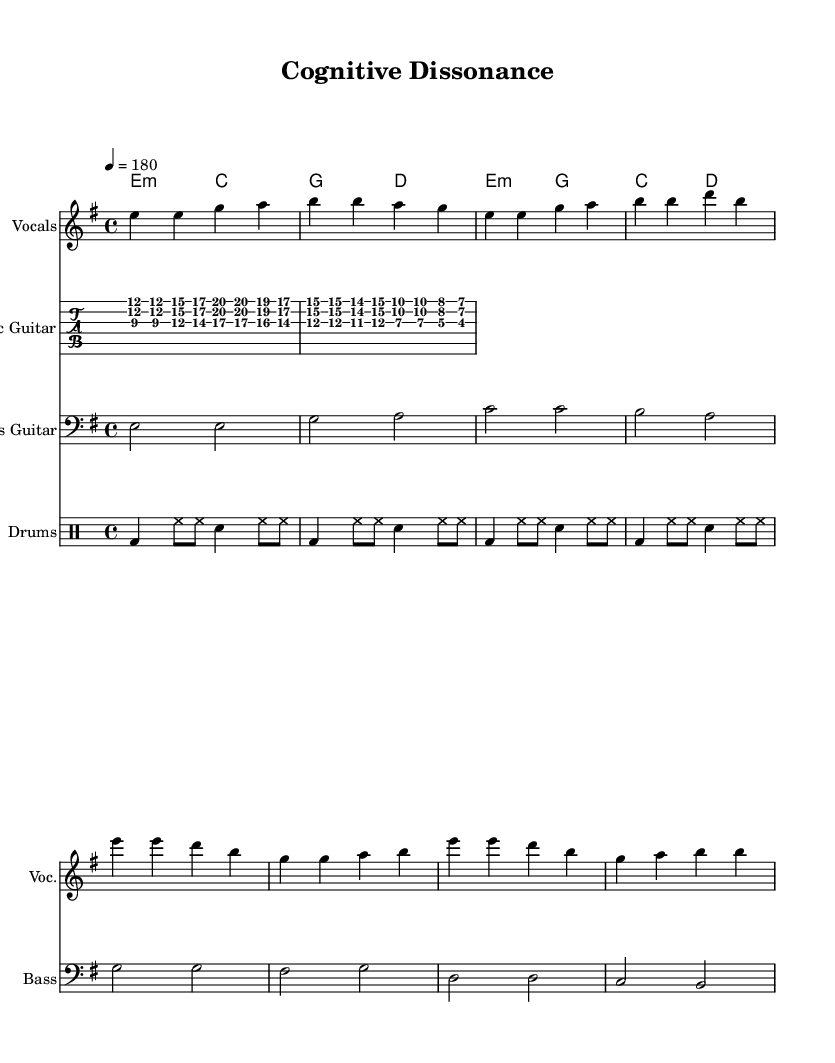What is the key signature of this music? The key signature is E minor, which has one sharp (F#). You can identify the key signature in the sheet music, typically at the beginning, represented by the number of sharps or flats present.
Answer: E minor What is the time signature of this music? The time signature is 4/4, as indicated at the beginning of the score. This means there are four beats in each measure, and the quarter note receives one beat.
Answer: 4/4 What is the tempo marking for this piece? The tempo marking is quarter note = 180. This indicates that one quarter note should be played at a speed of 180 beats per minute. It can be found at the start section of the sheet music.
Answer: 180 How many measures are in the verse section? The verse section contains 8 measures, which is determined by counting the groups of four beats (4/4 time) in the vocal part.
Answer: 8 What is the primary theme expressed in this punk track? The primary theme is cognitive dissonance, as indicated by the title of the piece. This reflects a contrast in thoughts and behaviors, a common topic explored in punk music, often addressing personal struggles.
Answer: Cognitive dissonance What instruments are featured in this punk music piece? The instruments featured include Electric Guitar, Bass Guitar, Drums, and Vocals, which can be identified by the separate staves for each instrument in the score.
Answer: Electric Guitar, Bass Guitar, Drums, Vocals What is the structure of the chorus in this piece? The chorus consists of a repeated melody and chord progression that provides a contrast to the verse, highlighted by the change in lyrics and a lift in energy typical in punk music. The specific arrangement can be traced in the vocal and chords parts.
Answer: Repeated melody and chord progression 